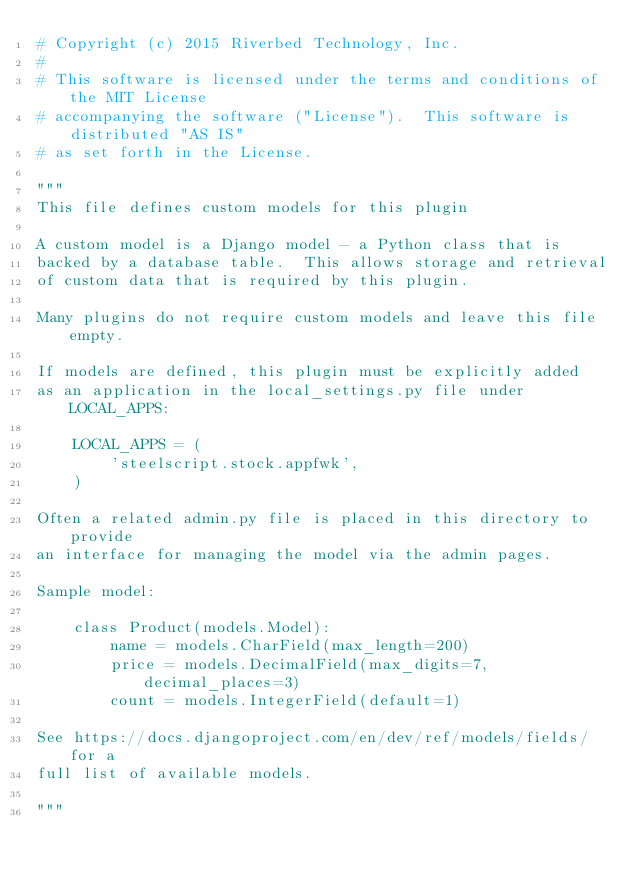<code> <loc_0><loc_0><loc_500><loc_500><_Python_># Copyright (c) 2015 Riverbed Technology, Inc.
#
# This software is licensed under the terms and conditions of the MIT License
# accompanying the software ("License").  This software is distributed "AS IS"
# as set forth in the License.

"""
This file defines custom models for this plugin

A custom model is a Django model - a Python class that is
backed by a database table.  This allows storage and retrieval
of custom data that is required by this plugin.

Many plugins do not require custom models and leave this file empty.

If models are defined, this plugin must be explicitly added
as an application in the local_settings.py file under LOCAL_APPS:

    LOCAL_APPS = (
        'steelscript.stock.appfwk',
    )

Often a related admin.py file is placed in this directory to provide
an interface for managing the model via the admin pages.

Sample model:

    class Product(models.Model):
        name = models.CharField(max_length=200)
        price = models.DecimalField(max_digits=7, decimal_places=3)
        count = models.IntegerField(default=1)

See https://docs.djangoproject.com/en/dev/ref/models/fields/ for a
full list of available models.

"""
</code> 